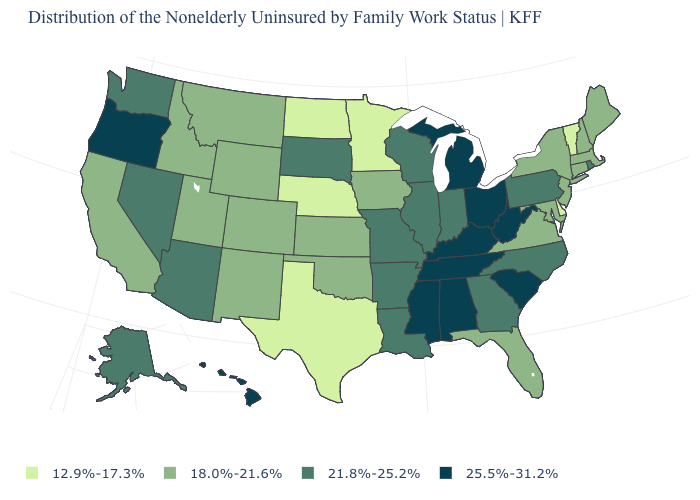Among the states that border Pennsylvania , which have the lowest value?
Answer briefly. Delaware. What is the value of Maine?
Give a very brief answer. 18.0%-21.6%. What is the value of Maryland?
Answer briefly. 18.0%-21.6%. What is the value of Arizona?
Quick response, please. 21.8%-25.2%. Name the states that have a value in the range 25.5%-31.2%?
Keep it brief. Alabama, Hawaii, Kentucky, Michigan, Mississippi, Ohio, Oregon, South Carolina, Tennessee, West Virginia. Does Massachusetts have a higher value than Vermont?
Be succinct. Yes. Among the states that border Missouri , which have the highest value?
Concise answer only. Kentucky, Tennessee. Name the states that have a value in the range 18.0%-21.6%?
Keep it brief. California, Colorado, Connecticut, Florida, Idaho, Iowa, Kansas, Maine, Maryland, Massachusetts, Montana, New Hampshire, New Jersey, New Mexico, New York, Oklahoma, Utah, Virginia, Wyoming. What is the value of Michigan?
Be succinct. 25.5%-31.2%. Which states hav the highest value in the South?
Concise answer only. Alabama, Kentucky, Mississippi, South Carolina, Tennessee, West Virginia. Name the states that have a value in the range 21.8%-25.2%?
Write a very short answer. Alaska, Arizona, Arkansas, Georgia, Illinois, Indiana, Louisiana, Missouri, Nevada, North Carolina, Pennsylvania, Rhode Island, South Dakota, Washington, Wisconsin. Which states have the highest value in the USA?
Answer briefly. Alabama, Hawaii, Kentucky, Michigan, Mississippi, Ohio, Oregon, South Carolina, Tennessee, West Virginia. What is the highest value in states that border Tennessee?
Quick response, please. 25.5%-31.2%. Name the states that have a value in the range 18.0%-21.6%?
Write a very short answer. California, Colorado, Connecticut, Florida, Idaho, Iowa, Kansas, Maine, Maryland, Massachusetts, Montana, New Hampshire, New Jersey, New Mexico, New York, Oklahoma, Utah, Virginia, Wyoming. Which states hav the highest value in the West?
Be succinct. Hawaii, Oregon. 